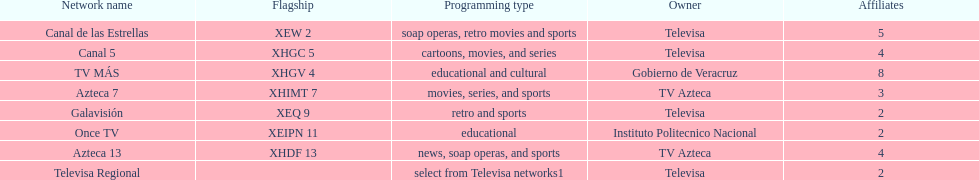How many tv stations are under the ownership of tv azteca? 2. 